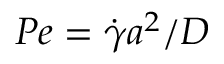Convert formula to latex. <formula><loc_0><loc_0><loc_500><loc_500>P e = \dot { \gamma } a ^ { 2 } / D</formula> 